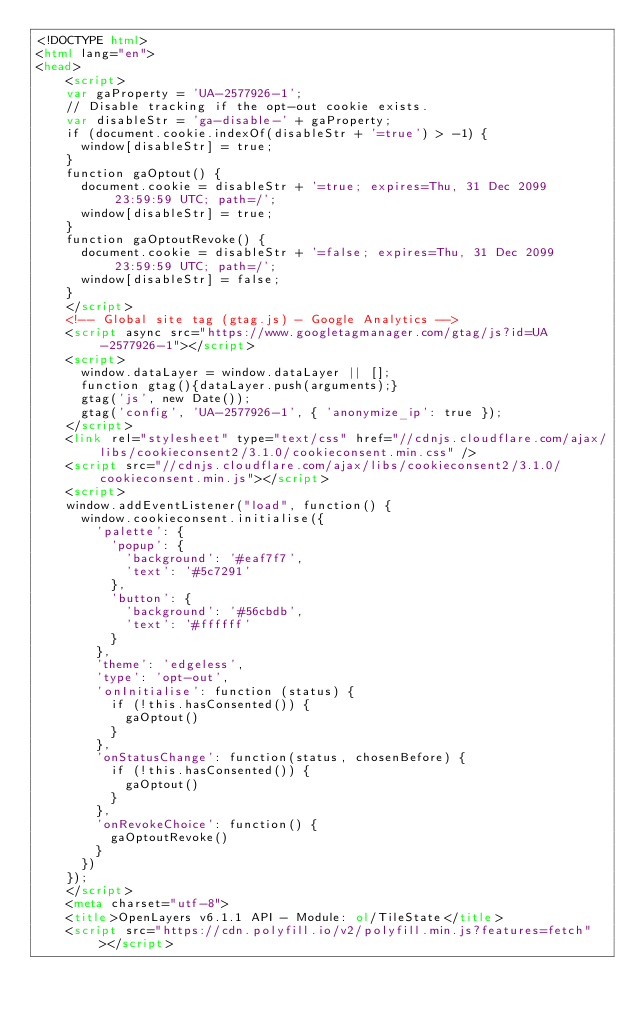Convert code to text. <code><loc_0><loc_0><loc_500><loc_500><_HTML_><!DOCTYPE html>
<html lang="en">
<head>
    <script>
    var gaProperty = 'UA-2577926-1';
    // Disable tracking if the opt-out cookie exists.
    var disableStr = 'ga-disable-' + gaProperty;
    if (document.cookie.indexOf(disableStr + '=true') > -1) {
      window[disableStr] = true;
    }
    function gaOptout() {
      document.cookie = disableStr + '=true; expires=Thu, 31 Dec 2099 23:59:59 UTC; path=/';
      window[disableStr] = true;
    }
    function gaOptoutRevoke() {
      document.cookie = disableStr + '=false; expires=Thu, 31 Dec 2099 23:59:59 UTC; path=/';
      window[disableStr] = false;
    }
    </script>
    <!-- Global site tag (gtag.js) - Google Analytics -->
    <script async src="https://www.googletagmanager.com/gtag/js?id=UA-2577926-1"></script>
    <script>
      window.dataLayer = window.dataLayer || [];
      function gtag(){dataLayer.push(arguments);}
      gtag('js', new Date());
      gtag('config', 'UA-2577926-1', { 'anonymize_ip': true });
    </script>
    <link rel="stylesheet" type="text/css" href="//cdnjs.cloudflare.com/ajax/libs/cookieconsent2/3.1.0/cookieconsent.min.css" />
    <script src="//cdnjs.cloudflare.com/ajax/libs/cookieconsent2/3.1.0/cookieconsent.min.js"></script>
    <script>
    window.addEventListener("load", function() {
      window.cookieconsent.initialise({
        'palette': {
          'popup': {
            'background': '#eaf7f7',
            'text': '#5c7291'
          },
          'button': {
            'background': '#56cbdb',
            'text': '#ffffff'
          }
        },
        'theme': 'edgeless',
        'type': 'opt-out',
        'onInitialise': function (status) {
          if (!this.hasConsented()) {
            gaOptout()
          }
        },
        'onStatusChange': function(status, chosenBefore) {
          if (!this.hasConsented()) {
            gaOptout()
          }
        },
        'onRevokeChoice': function() {
          gaOptoutRevoke()
        }
      })
    });
    </script>
    <meta charset="utf-8">
    <title>OpenLayers v6.1.1 API - Module: ol/TileState</title>
    <script src="https://cdn.polyfill.io/v2/polyfill.min.js?features=fetch"></script></code> 